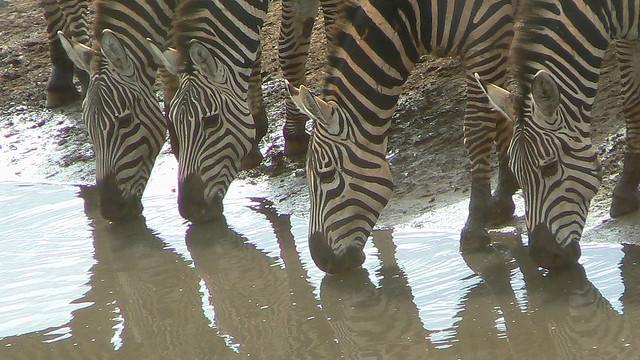What predator do these animals need to be careful of right now?
Keep it brief. Lion. Is the zebra on the far right drinking water?
Concise answer only. Yes. What colors are the animals?
Quick response, please. Black and white. How many zebras are there?
Quick response, please. 4. 